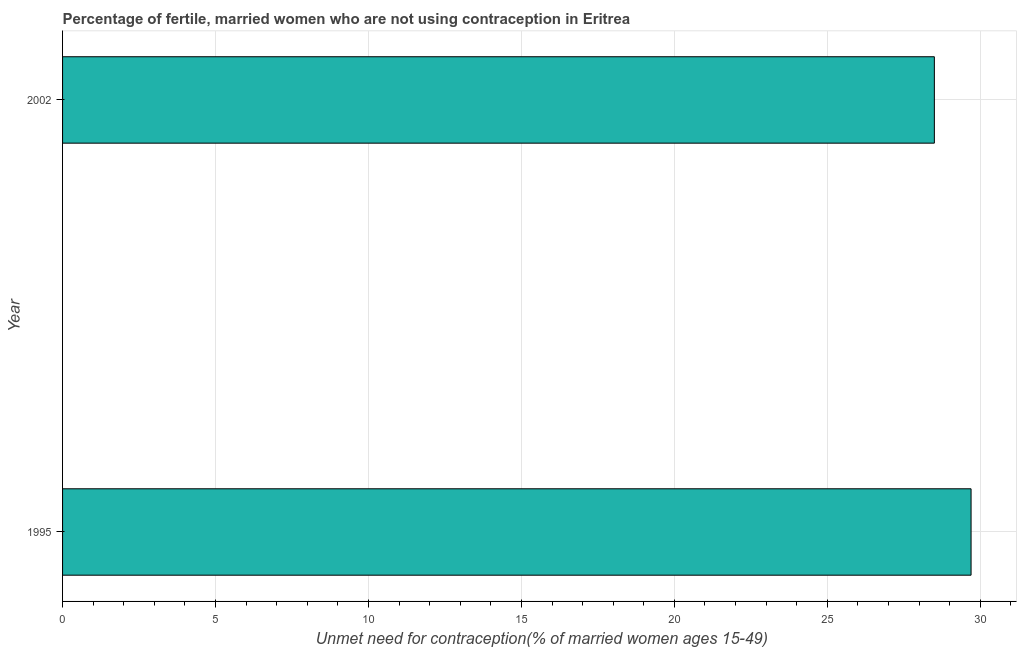Does the graph contain any zero values?
Provide a short and direct response. No. What is the title of the graph?
Ensure brevity in your answer.  Percentage of fertile, married women who are not using contraception in Eritrea. What is the label or title of the X-axis?
Your answer should be compact.  Unmet need for contraception(% of married women ages 15-49). What is the number of married women who are not using contraception in 1995?
Ensure brevity in your answer.  29.7. Across all years, what is the maximum number of married women who are not using contraception?
Keep it short and to the point. 29.7. In which year was the number of married women who are not using contraception maximum?
Offer a very short reply. 1995. What is the sum of the number of married women who are not using contraception?
Provide a short and direct response. 58.2. What is the difference between the number of married women who are not using contraception in 1995 and 2002?
Your answer should be very brief. 1.2. What is the average number of married women who are not using contraception per year?
Provide a succinct answer. 29.1. What is the median number of married women who are not using contraception?
Provide a short and direct response. 29.1. In how many years, is the number of married women who are not using contraception greater than 2 %?
Ensure brevity in your answer.  2. Do a majority of the years between 2002 and 1995 (inclusive) have number of married women who are not using contraception greater than 2 %?
Provide a short and direct response. No. What is the ratio of the number of married women who are not using contraception in 1995 to that in 2002?
Your answer should be compact. 1.04. Are all the bars in the graph horizontal?
Provide a short and direct response. Yes. What is the difference between two consecutive major ticks on the X-axis?
Keep it short and to the point. 5. What is the  Unmet need for contraception(% of married women ages 15-49) of 1995?
Offer a very short reply. 29.7. What is the  Unmet need for contraception(% of married women ages 15-49) of 2002?
Your answer should be compact. 28.5. What is the difference between the  Unmet need for contraception(% of married women ages 15-49) in 1995 and 2002?
Ensure brevity in your answer.  1.2. What is the ratio of the  Unmet need for contraception(% of married women ages 15-49) in 1995 to that in 2002?
Offer a very short reply. 1.04. 